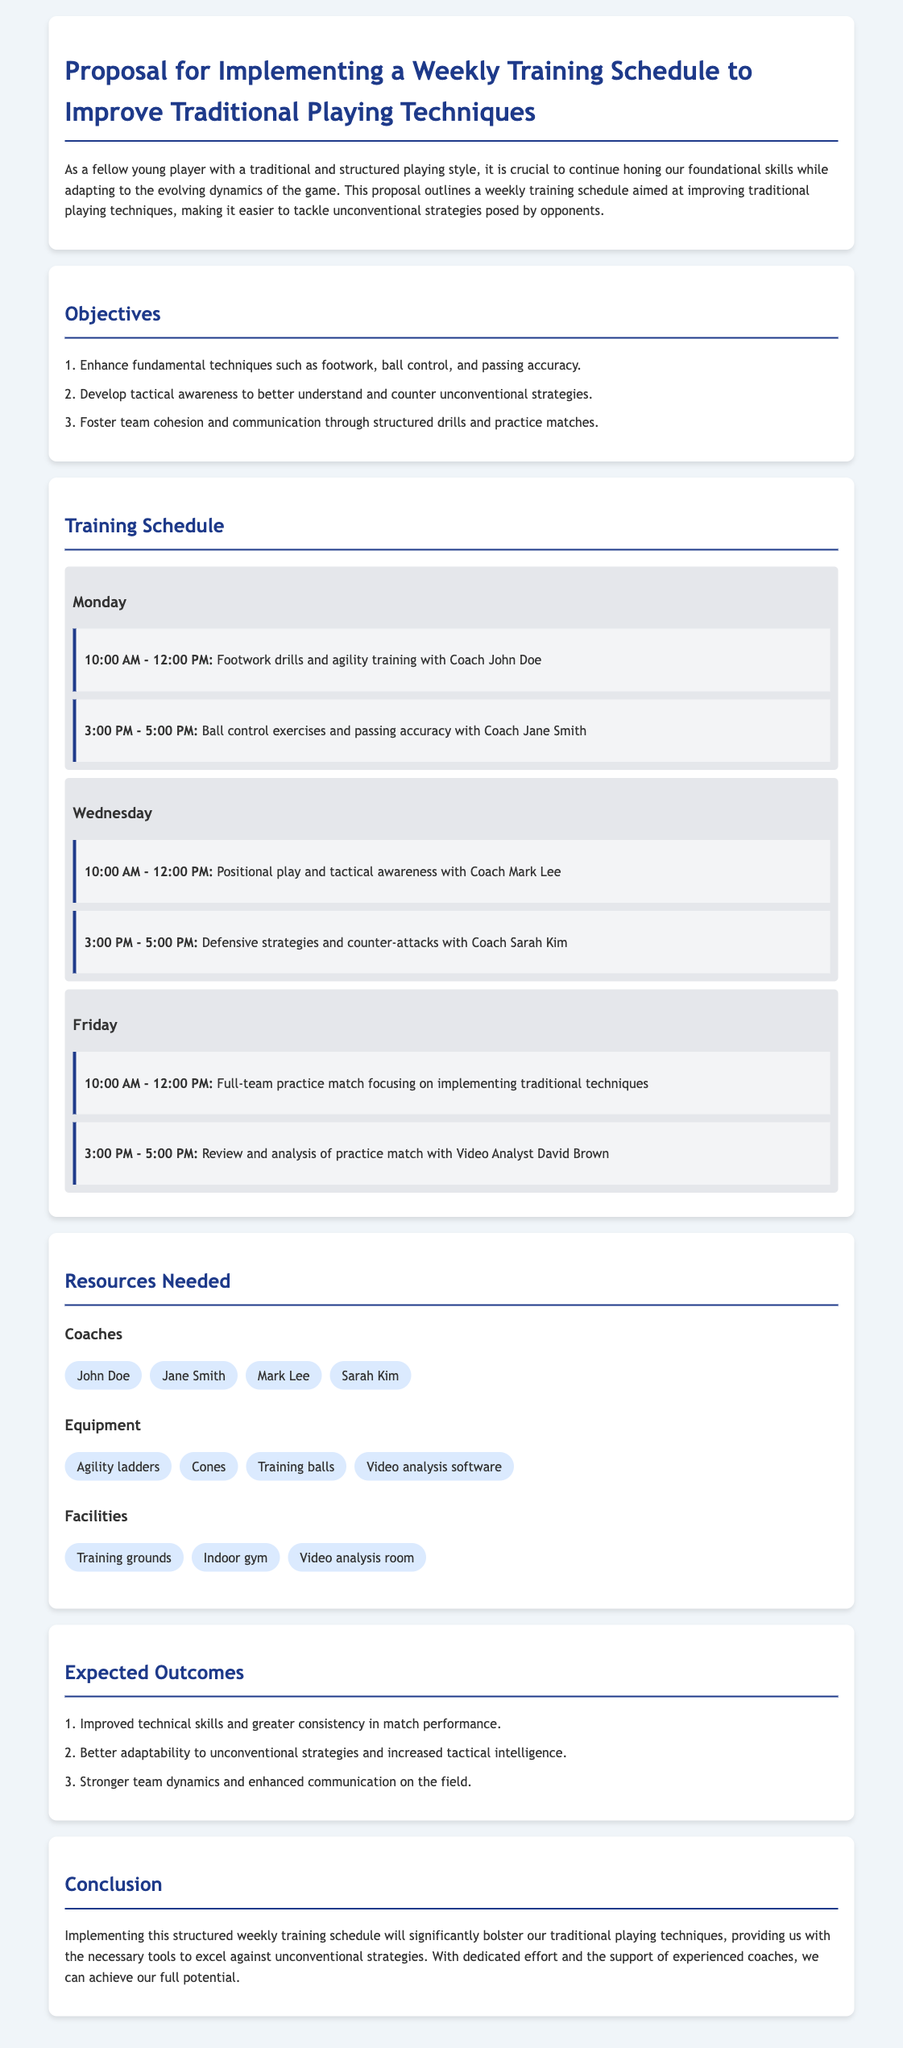What is the main purpose of the proposal? The purpose of the proposal is outlined in the introduction, focusing on improving traditional playing techniques through a structured training schedule.
Answer: Improve traditional playing techniques Who are the four coaches involved in the training schedule? The coaches listed in the resources section are essential for the training program, and their names are mentioned therein.
Answer: John Doe, Jane Smith, Mark Lee, Sarah Kim How many training days are scheduled each week? The training schedule is divided across three days, as presented in the schedule section.
Answer: Three What is the duration of the Friday practice match? The practice match duration is specified in the Friday schedule section, indicating the total time allocated for this activity.
Answer: Two hours Which activity focuses on tactical awareness? The specified activity focusing on tactical awareness on Wednesday is detailed in the training schedule, making it easy to identify.
Answer: Positional play and tactical awareness What equipment is listed for the training sessions? The equipment section outlines necessary items to facilitate the training described in the proposal.
Answer: Agility ladders, cones, training balls, video analysis software What is the expected outcome regarding team dynamics? The expected outcomes section explicitly mentions improvement in team dynamics as one of the results of the proposed training schedule.
Answer: Stronger team dynamics What time does Monday's footwork drills start? The training schedule clearly states the start time for the footwork drills on Monday, providing specific timing information.
Answer: 10:00 AM 